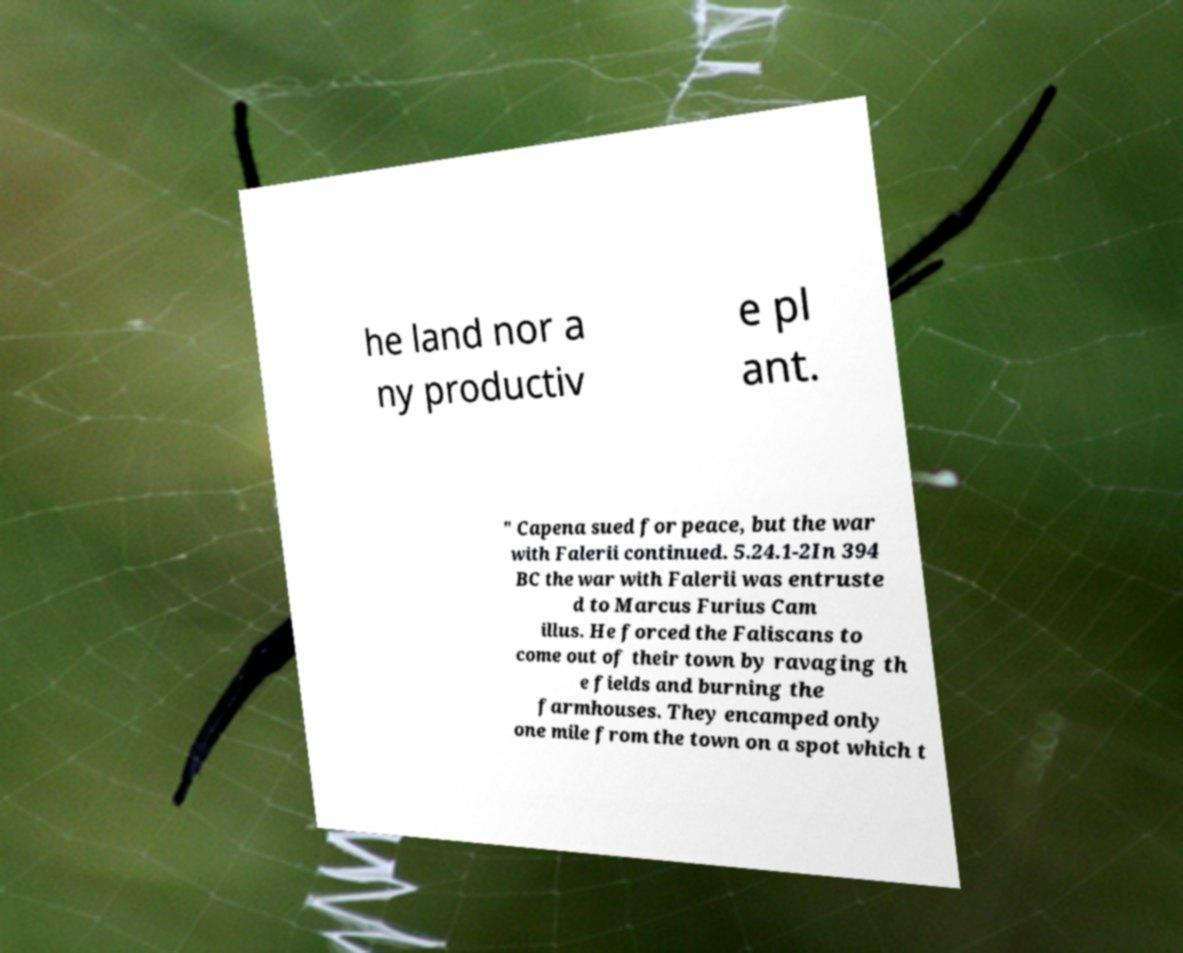Can you accurately transcribe the text from the provided image for me? he land nor a ny productiv e pl ant. " Capena sued for peace, but the war with Falerii continued. 5.24.1-2In 394 BC the war with Falerii was entruste d to Marcus Furius Cam illus. He forced the Faliscans to come out of their town by ravaging th e fields and burning the farmhouses. They encamped only one mile from the town on a spot which t 